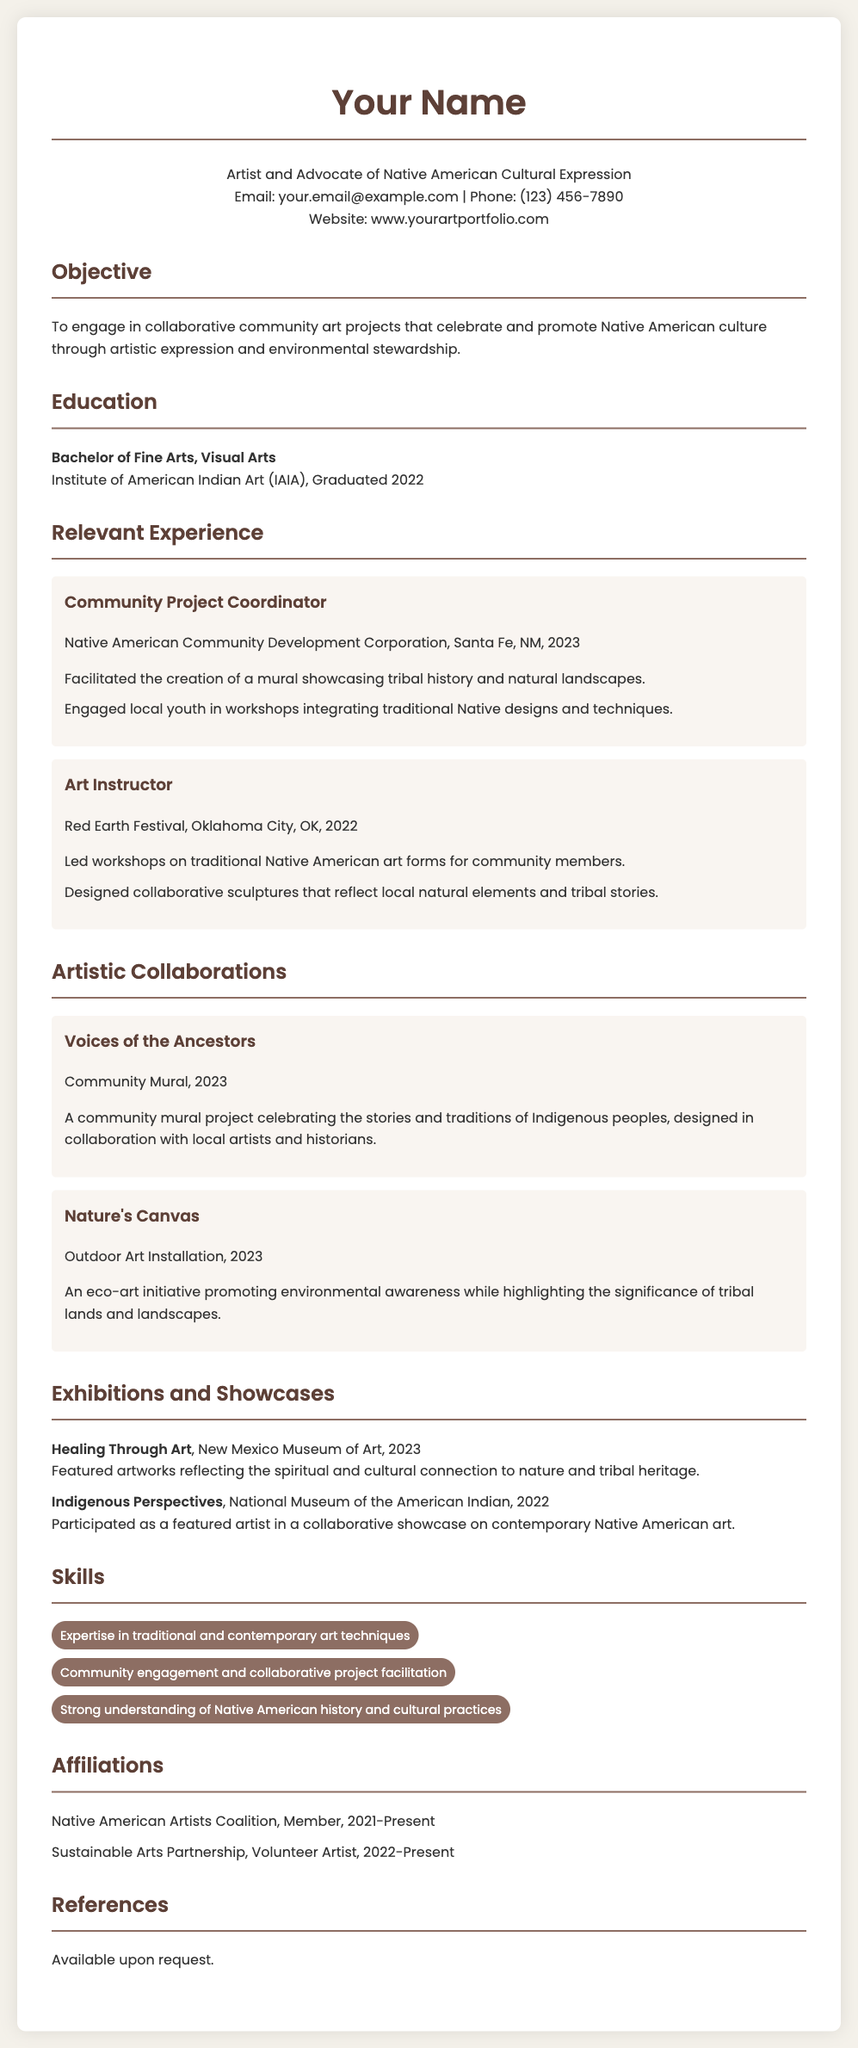what is the name of the artist? The artist's name is displayed prominently at the top of the CV.
Answer: Your Name what is the educational qualification of the artist? The education section lists the artist's degree and institution attended.
Answer: Bachelor of Fine Arts, Visual Arts in which year did the artist graduate? The graduation year is mentioned under the education section.
Answer: 2022 which organization did the artist coordinate a community project for? The relevant experience section specifies the organization where the artist worked.
Answer: Native American Community Development Corporation what is the title of the mural project completed in 2023? The title of the project can be found in the artistic collaborations section.
Answer: Voices of the Ancestors how many skills are listed in the skills section? The skills section includes a list of specific skill items.
Answer: Three which exhibition featured artworks reflecting spiritual and cultural connections to nature? The exhibitions section names this specific exhibition.
Answer: Healing Through Art what is the role of the artist in the Native American Artists Coalition? The affiliations section details the artist's membership role.
Answer: Member how many years of experience does the artist have as a volunteer artist? The affiliations section indicates the duration of the artist's volunteer work.
Answer: Two years 